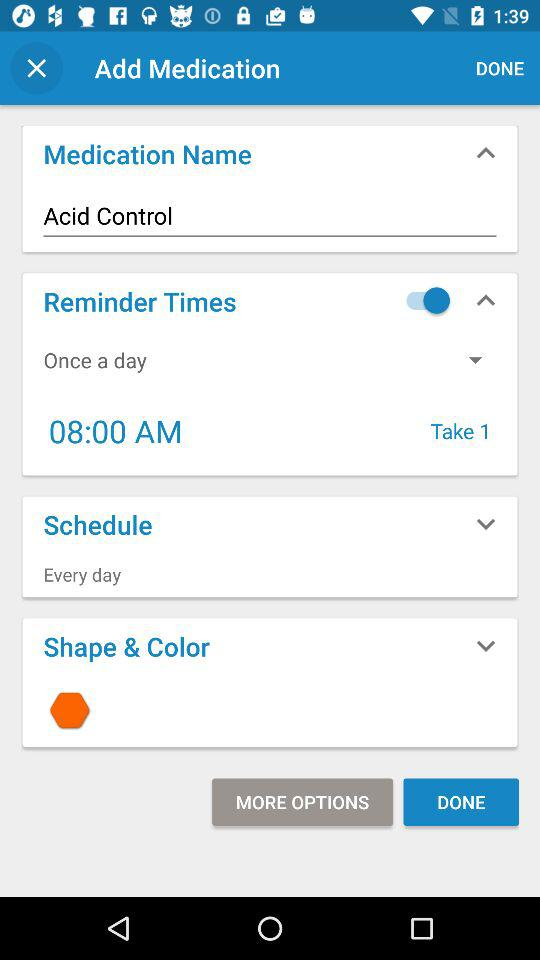What is the shape of the medication?
Answer the question using a single word or phrase. Hexagon 